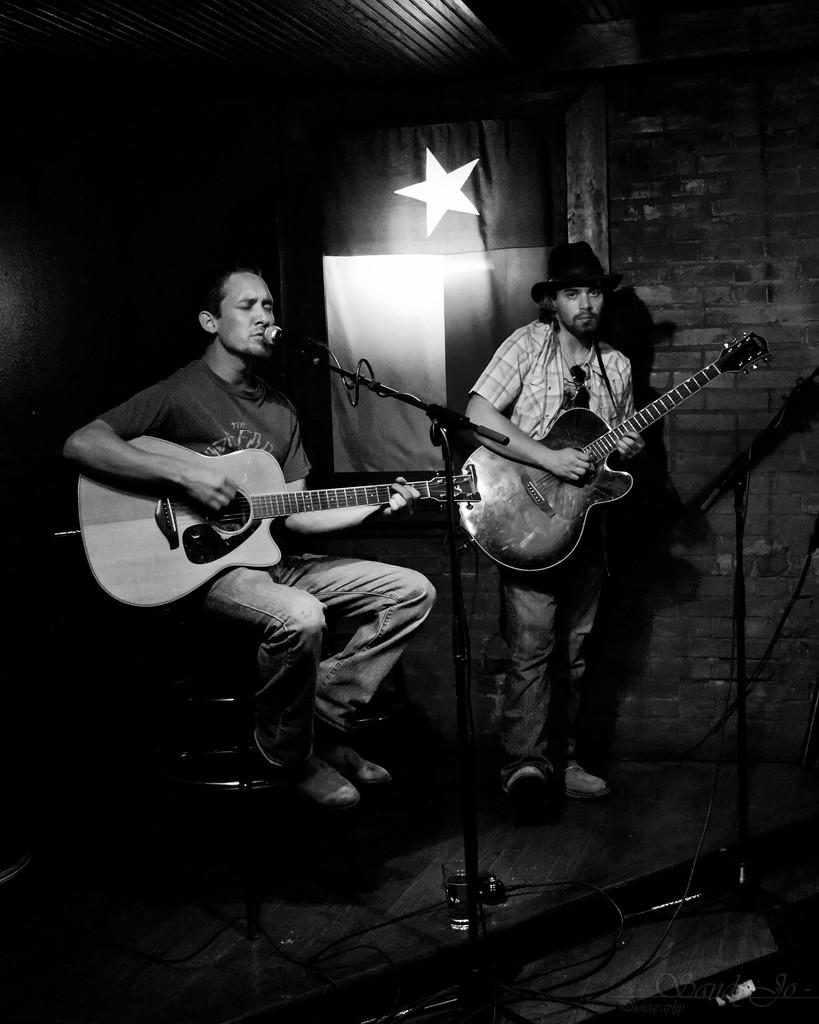What is the person on the left side of the image doing? The person on the left is playing a guitar and singing. What object is the person on the left using for amplification? The person on the left is in front of a microphone. What is the second person doing in the image? The second person is standing and playing a guitar. How much motion can be observed in the image? The image does not depict motion; it is a still image of two people playing guitars and singing. What type of team is visible in the image? There is no team present in the image; it features two individuals playing guitars and singing. 